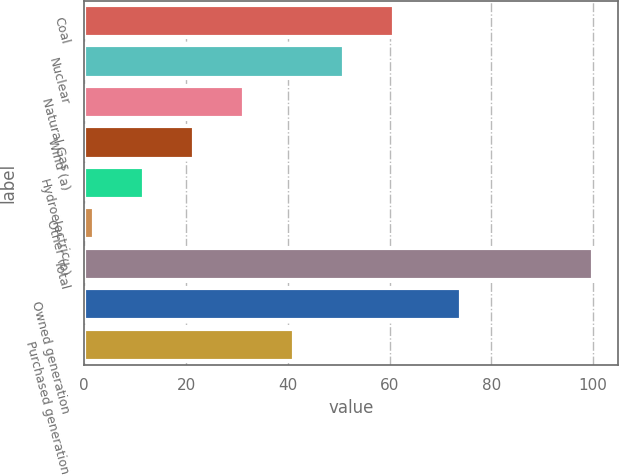Convert chart. <chart><loc_0><loc_0><loc_500><loc_500><bar_chart><fcel>Coal<fcel>Nuclear<fcel>Natural Gas<fcel>Wind (a)<fcel>Hydroelectric<fcel>Other (b)<fcel>Total<fcel>Owned generation<fcel>Purchased generation<nl><fcel>60.8<fcel>51<fcel>31.4<fcel>21.6<fcel>11.8<fcel>2<fcel>100<fcel>74<fcel>41.2<nl></chart> 